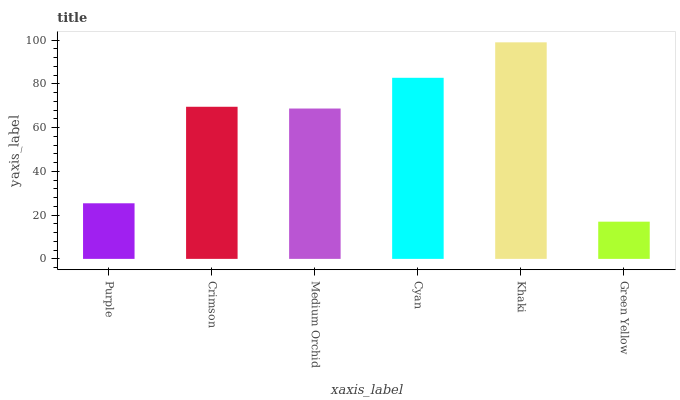Is Green Yellow the minimum?
Answer yes or no. Yes. Is Khaki the maximum?
Answer yes or no. Yes. Is Crimson the minimum?
Answer yes or no. No. Is Crimson the maximum?
Answer yes or no. No. Is Crimson greater than Purple?
Answer yes or no. Yes. Is Purple less than Crimson?
Answer yes or no. Yes. Is Purple greater than Crimson?
Answer yes or no. No. Is Crimson less than Purple?
Answer yes or no. No. Is Crimson the high median?
Answer yes or no. Yes. Is Medium Orchid the low median?
Answer yes or no. Yes. Is Cyan the high median?
Answer yes or no. No. Is Cyan the low median?
Answer yes or no. No. 